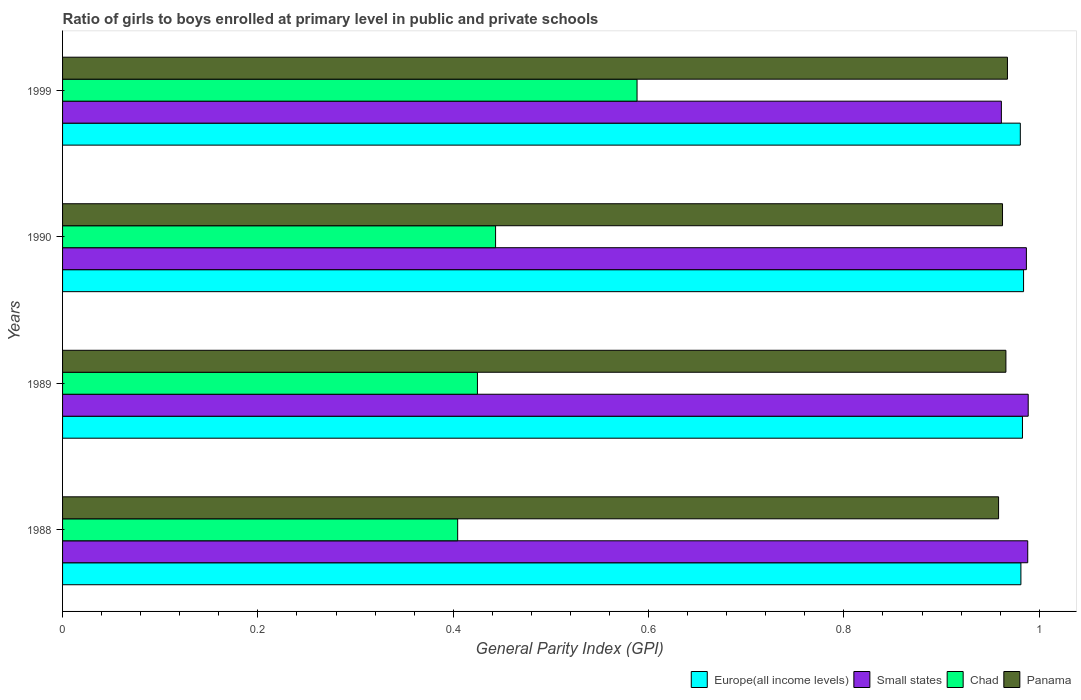How many different coloured bars are there?
Your answer should be very brief. 4. Are the number of bars per tick equal to the number of legend labels?
Ensure brevity in your answer.  Yes. Are the number of bars on each tick of the Y-axis equal?
Provide a short and direct response. Yes. How many bars are there on the 2nd tick from the bottom?
Give a very brief answer. 4. In how many cases, is the number of bars for a given year not equal to the number of legend labels?
Keep it short and to the point. 0. What is the general parity index in Panama in 1989?
Keep it short and to the point. 0.97. Across all years, what is the maximum general parity index in Small states?
Give a very brief answer. 0.99. Across all years, what is the minimum general parity index in Panama?
Give a very brief answer. 0.96. In which year was the general parity index in Panama minimum?
Offer a very short reply. 1988. What is the total general parity index in Chad in the graph?
Give a very brief answer. 1.86. What is the difference between the general parity index in Panama in 1989 and that in 1999?
Offer a terse response. -0. What is the difference between the general parity index in Panama in 1988 and the general parity index in Chad in 1989?
Give a very brief answer. 0.53. What is the average general parity index in Europe(all income levels) per year?
Keep it short and to the point. 0.98. In the year 1989, what is the difference between the general parity index in Europe(all income levels) and general parity index in Small states?
Make the answer very short. -0.01. In how many years, is the general parity index in Chad greater than 0.7600000000000001 ?
Ensure brevity in your answer.  0. What is the ratio of the general parity index in Europe(all income levels) in 1988 to that in 1989?
Ensure brevity in your answer.  1. Is the general parity index in Panama in 1989 less than that in 1990?
Offer a terse response. No. What is the difference between the highest and the second highest general parity index in Small states?
Give a very brief answer. 0. What is the difference between the highest and the lowest general parity index in Chad?
Make the answer very short. 0.18. In how many years, is the general parity index in Panama greater than the average general parity index in Panama taken over all years?
Offer a very short reply. 2. Is the sum of the general parity index in Europe(all income levels) in 1988 and 1989 greater than the maximum general parity index in Chad across all years?
Ensure brevity in your answer.  Yes. What does the 3rd bar from the top in 1988 represents?
Offer a terse response. Small states. What does the 2nd bar from the bottom in 1988 represents?
Make the answer very short. Small states. What is the difference between two consecutive major ticks on the X-axis?
Ensure brevity in your answer.  0.2. Does the graph contain grids?
Your response must be concise. No. How are the legend labels stacked?
Offer a terse response. Horizontal. What is the title of the graph?
Your answer should be compact. Ratio of girls to boys enrolled at primary level in public and private schools. What is the label or title of the X-axis?
Your response must be concise. General Parity Index (GPI). What is the General Parity Index (GPI) of Europe(all income levels) in 1988?
Your answer should be compact. 0.98. What is the General Parity Index (GPI) of Small states in 1988?
Your answer should be compact. 0.99. What is the General Parity Index (GPI) in Chad in 1988?
Your answer should be compact. 0.4. What is the General Parity Index (GPI) in Panama in 1988?
Offer a very short reply. 0.96. What is the General Parity Index (GPI) of Europe(all income levels) in 1989?
Offer a terse response. 0.98. What is the General Parity Index (GPI) of Small states in 1989?
Offer a very short reply. 0.99. What is the General Parity Index (GPI) of Chad in 1989?
Make the answer very short. 0.42. What is the General Parity Index (GPI) in Panama in 1989?
Provide a succinct answer. 0.97. What is the General Parity Index (GPI) of Europe(all income levels) in 1990?
Make the answer very short. 0.98. What is the General Parity Index (GPI) of Small states in 1990?
Offer a very short reply. 0.99. What is the General Parity Index (GPI) of Chad in 1990?
Your response must be concise. 0.44. What is the General Parity Index (GPI) in Panama in 1990?
Your response must be concise. 0.96. What is the General Parity Index (GPI) of Europe(all income levels) in 1999?
Ensure brevity in your answer.  0.98. What is the General Parity Index (GPI) in Small states in 1999?
Your response must be concise. 0.96. What is the General Parity Index (GPI) in Chad in 1999?
Your response must be concise. 0.59. What is the General Parity Index (GPI) of Panama in 1999?
Provide a short and direct response. 0.97. Across all years, what is the maximum General Parity Index (GPI) of Europe(all income levels)?
Offer a very short reply. 0.98. Across all years, what is the maximum General Parity Index (GPI) in Small states?
Give a very brief answer. 0.99. Across all years, what is the maximum General Parity Index (GPI) of Chad?
Your answer should be compact. 0.59. Across all years, what is the maximum General Parity Index (GPI) in Panama?
Provide a succinct answer. 0.97. Across all years, what is the minimum General Parity Index (GPI) in Europe(all income levels)?
Keep it short and to the point. 0.98. Across all years, what is the minimum General Parity Index (GPI) in Small states?
Your response must be concise. 0.96. Across all years, what is the minimum General Parity Index (GPI) in Chad?
Provide a succinct answer. 0.4. Across all years, what is the minimum General Parity Index (GPI) of Panama?
Your answer should be compact. 0.96. What is the total General Parity Index (GPI) in Europe(all income levels) in the graph?
Your answer should be compact. 3.93. What is the total General Parity Index (GPI) in Small states in the graph?
Keep it short and to the point. 3.93. What is the total General Parity Index (GPI) in Chad in the graph?
Your answer should be very brief. 1.86. What is the total General Parity Index (GPI) of Panama in the graph?
Provide a short and direct response. 3.85. What is the difference between the General Parity Index (GPI) of Europe(all income levels) in 1988 and that in 1989?
Offer a terse response. -0. What is the difference between the General Parity Index (GPI) of Small states in 1988 and that in 1989?
Provide a short and direct response. -0. What is the difference between the General Parity Index (GPI) of Chad in 1988 and that in 1989?
Ensure brevity in your answer.  -0.02. What is the difference between the General Parity Index (GPI) of Panama in 1988 and that in 1989?
Provide a short and direct response. -0.01. What is the difference between the General Parity Index (GPI) in Europe(all income levels) in 1988 and that in 1990?
Your response must be concise. -0. What is the difference between the General Parity Index (GPI) in Small states in 1988 and that in 1990?
Keep it short and to the point. 0. What is the difference between the General Parity Index (GPI) in Chad in 1988 and that in 1990?
Offer a very short reply. -0.04. What is the difference between the General Parity Index (GPI) of Panama in 1988 and that in 1990?
Provide a succinct answer. -0. What is the difference between the General Parity Index (GPI) in Europe(all income levels) in 1988 and that in 1999?
Provide a succinct answer. 0. What is the difference between the General Parity Index (GPI) of Small states in 1988 and that in 1999?
Keep it short and to the point. 0.03. What is the difference between the General Parity Index (GPI) of Chad in 1988 and that in 1999?
Keep it short and to the point. -0.18. What is the difference between the General Parity Index (GPI) of Panama in 1988 and that in 1999?
Provide a succinct answer. -0.01. What is the difference between the General Parity Index (GPI) of Europe(all income levels) in 1989 and that in 1990?
Make the answer very short. -0. What is the difference between the General Parity Index (GPI) in Small states in 1989 and that in 1990?
Ensure brevity in your answer.  0. What is the difference between the General Parity Index (GPI) in Chad in 1989 and that in 1990?
Give a very brief answer. -0.02. What is the difference between the General Parity Index (GPI) in Panama in 1989 and that in 1990?
Provide a succinct answer. 0. What is the difference between the General Parity Index (GPI) in Europe(all income levels) in 1989 and that in 1999?
Offer a very short reply. 0. What is the difference between the General Parity Index (GPI) of Small states in 1989 and that in 1999?
Your answer should be very brief. 0.03. What is the difference between the General Parity Index (GPI) of Chad in 1989 and that in 1999?
Ensure brevity in your answer.  -0.16. What is the difference between the General Parity Index (GPI) of Panama in 1989 and that in 1999?
Make the answer very short. -0. What is the difference between the General Parity Index (GPI) of Europe(all income levels) in 1990 and that in 1999?
Provide a short and direct response. 0. What is the difference between the General Parity Index (GPI) in Small states in 1990 and that in 1999?
Ensure brevity in your answer.  0.03. What is the difference between the General Parity Index (GPI) of Chad in 1990 and that in 1999?
Your answer should be very brief. -0.14. What is the difference between the General Parity Index (GPI) of Panama in 1990 and that in 1999?
Keep it short and to the point. -0.01. What is the difference between the General Parity Index (GPI) of Europe(all income levels) in 1988 and the General Parity Index (GPI) of Small states in 1989?
Make the answer very short. -0.01. What is the difference between the General Parity Index (GPI) of Europe(all income levels) in 1988 and the General Parity Index (GPI) of Chad in 1989?
Keep it short and to the point. 0.56. What is the difference between the General Parity Index (GPI) of Europe(all income levels) in 1988 and the General Parity Index (GPI) of Panama in 1989?
Provide a short and direct response. 0.02. What is the difference between the General Parity Index (GPI) in Small states in 1988 and the General Parity Index (GPI) in Chad in 1989?
Offer a very short reply. 0.56. What is the difference between the General Parity Index (GPI) of Small states in 1988 and the General Parity Index (GPI) of Panama in 1989?
Provide a short and direct response. 0.02. What is the difference between the General Parity Index (GPI) of Chad in 1988 and the General Parity Index (GPI) of Panama in 1989?
Offer a terse response. -0.56. What is the difference between the General Parity Index (GPI) in Europe(all income levels) in 1988 and the General Parity Index (GPI) in Small states in 1990?
Make the answer very short. -0.01. What is the difference between the General Parity Index (GPI) of Europe(all income levels) in 1988 and the General Parity Index (GPI) of Chad in 1990?
Offer a terse response. 0.54. What is the difference between the General Parity Index (GPI) of Europe(all income levels) in 1988 and the General Parity Index (GPI) of Panama in 1990?
Your response must be concise. 0.02. What is the difference between the General Parity Index (GPI) in Small states in 1988 and the General Parity Index (GPI) in Chad in 1990?
Make the answer very short. 0.54. What is the difference between the General Parity Index (GPI) in Small states in 1988 and the General Parity Index (GPI) in Panama in 1990?
Your answer should be compact. 0.03. What is the difference between the General Parity Index (GPI) of Chad in 1988 and the General Parity Index (GPI) of Panama in 1990?
Keep it short and to the point. -0.56. What is the difference between the General Parity Index (GPI) of Europe(all income levels) in 1988 and the General Parity Index (GPI) of Chad in 1999?
Your response must be concise. 0.39. What is the difference between the General Parity Index (GPI) of Europe(all income levels) in 1988 and the General Parity Index (GPI) of Panama in 1999?
Your answer should be compact. 0.01. What is the difference between the General Parity Index (GPI) of Small states in 1988 and the General Parity Index (GPI) of Panama in 1999?
Make the answer very short. 0.02. What is the difference between the General Parity Index (GPI) in Chad in 1988 and the General Parity Index (GPI) in Panama in 1999?
Offer a very short reply. -0.56. What is the difference between the General Parity Index (GPI) of Europe(all income levels) in 1989 and the General Parity Index (GPI) of Small states in 1990?
Provide a succinct answer. -0. What is the difference between the General Parity Index (GPI) of Europe(all income levels) in 1989 and the General Parity Index (GPI) of Chad in 1990?
Your answer should be compact. 0.54. What is the difference between the General Parity Index (GPI) in Europe(all income levels) in 1989 and the General Parity Index (GPI) in Panama in 1990?
Your response must be concise. 0.02. What is the difference between the General Parity Index (GPI) of Small states in 1989 and the General Parity Index (GPI) of Chad in 1990?
Offer a terse response. 0.55. What is the difference between the General Parity Index (GPI) in Small states in 1989 and the General Parity Index (GPI) in Panama in 1990?
Make the answer very short. 0.03. What is the difference between the General Parity Index (GPI) of Chad in 1989 and the General Parity Index (GPI) of Panama in 1990?
Your response must be concise. -0.54. What is the difference between the General Parity Index (GPI) of Europe(all income levels) in 1989 and the General Parity Index (GPI) of Small states in 1999?
Ensure brevity in your answer.  0.02. What is the difference between the General Parity Index (GPI) of Europe(all income levels) in 1989 and the General Parity Index (GPI) of Chad in 1999?
Offer a terse response. 0.39. What is the difference between the General Parity Index (GPI) in Europe(all income levels) in 1989 and the General Parity Index (GPI) in Panama in 1999?
Ensure brevity in your answer.  0.02. What is the difference between the General Parity Index (GPI) in Small states in 1989 and the General Parity Index (GPI) in Chad in 1999?
Ensure brevity in your answer.  0.4. What is the difference between the General Parity Index (GPI) of Small states in 1989 and the General Parity Index (GPI) of Panama in 1999?
Make the answer very short. 0.02. What is the difference between the General Parity Index (GPI) in Chad in 1989 and the General Parity Index (GPI) in Panama in 1999?
Give a very brief answer. -0.54. What is the difference between the General Parity Index (GPI) in Europe(all income levels) in 1990 and the General Parity Index (GPI) in Small states in 1999?
Offer a very short reply. 0.02. What is the difference between the General Parity Index (GPI) in Europe(all income levels) in 1990 and the General Parity Index (GPI) in Chad in 1999?
Provide a succinct answer. 0.4. What is the difference between the General Parity Index (GPI) in Europe(all income levels) in 1990 and the General Parity Index (GPI) in Panama in 1999?
Your response must be concise. 0.02. What is the difference between the General Parity Index (GPI) of Small states in 1990 and the General Parity Index (GPI) of Chad in 1999?
Ensure brevity in your answer.  0.4. What is the difference between the General Parity Index (GPI) of Small states in 1990 and the General Parity Index (GPI) of Panama in 1999?
Provide a succinct answer. 0.02. What is the difference between the General Parity Index (GPI) in Chad in 1990 and the General Parity Index (GPI) in Panama in 1999?
Your response must be concise. -0.52. What is the average General Parity Index (GPI) of Europe(all income levels) per year?
Offer a terse response. 0.98. What is the average General Parity Index (GPI) of Small states per year?
Ensure brevity in your answer.  0.98. What is the average General Parity Index (GPI) in Chad per year?
Provide a short and direct response. 0.47. What is the average General Parity Index (GPI) of Panama per year?
Provide a succinct answer. 0.96. In the year 1988, what is the difference between the General Parity Index (GPI) in Europe(all income levels) and General Parity Index (GPI) in Small states?
Offer a very short reply. -0.01. In the year 1988, what is the difference between the General Parity Index (GPI) in Europe(all income levels) and General Parity Index (GPI) in Chad?
Your answer should be very brief. 0.58. In the year 1988, what is the difference between the General Parity Index (GPI) of Europe(all income levels) and General Parity Index (GPI) of Panama?
Offer a terse response. 0.02. In the year 1988, what is the difference between the General Parity Index (GPI) of Small states and General Parity Index (GPI) of Chad?
Offer a very short reply. 0.58. In the year 1988, what is the difference between the General Parity Index (GPI) of Small states and General Parity Index (GPI) of Panama?
Provide a succinct answer. 0.03. In the year 1988, what is the difference between the General Parity Index (GPI) in Chad and General Parity Index (GPI) in Panama?
Ensure brevity in your answer.  -0.55. In the year 1989, what is the difference between the General Parity Index (GPI) in Europe(all income levels) and General Parity Index (GPI) in Small states?
Your answer should be compact. -0.01. In the year 1989, what is the difference between the General Parity Index (GPI) in Europe(all income levels) and General Parity Index (GPI) in Chad?
Offer a very short reply. 0.56. In the year 1989, what is the difference between the General Parity Index (GPI) of Europe(all income levels) and General Parity Index (GPI) of Panama?
Offer a very short reply. 0.02. In the year 1989, what is the difference between the General Parity Index (GPI) of Small states and General Parity Index (GPI) of Chad?
Keep it short and to the point. 0.56. In the year 1989, what is the difference between the General Parity Index (GPI) in Small states and General Parity Index (GPI) in Panama?
Your answer should be compact. 0.02. In the year 1989, what is the difference between the General Parity Index (GPI) of Chad and General Parity Index (GPI) of Panama?
Offer a very short reply. -0.54. In the year 1990, what is the difference between the General Parity Index (GPI) of Europe(all income levels) and General Parity Index (GPI) of Small states?
Offer a terse response. -0. In the year 1990, what is the difference between the General Parity Index (GPI) in Europe(all income levels) and General Parity Index (GPI) in Chad?
Provide a short and direct response. 0.54. In the year 1990, what is the difference between the General Parity Index (GPI) of Europe(all income levels) and General Parity Index (GPI) of Panama?
Your answer should be very brief. 0.02. In the year 1990, what is the difference between the General Parity Index (GPI) of Small states and General Parity Index (GPI) of Chad?
Offer a terse response. 0.54. In the year 1990, what is the difference between the General Parity Index (GPI) in Small states and General Parity Index (GPI) in Panama?
Your answer should be very brief. 0.02. In the year 1990, what is the difference between the General Parity Index (GPI) in Chad and General Parity Index (GPI) in Panama?
Your response must be concise. -0.52. In the year 1999, what is the difference between the General Parity Index (GPI) of Europe(all income levels) and General Parity Index (GPI) of Small states?
Give a very brief answer. 0.02. In the year 1999, what is the difference between the General Parity Index (GPI) of Europe(all income levels) and General Parity Index (GPI) of Chad?
Offer a terse response. 0.39. In the year 1999, what is the difference between the General Parity Index (GPI) of Europe(all income levels) and General Parity Index (GPI) of Panama?
Give a very brief answer. 0.01. In the year 1999, what is the difference between the General Parity Index (GPI) in Small states and General Parity Index (GPI) in Chad?
Offer a very short reply. 0.37. In the year 1999, what is the difference between the General Parity Index (GPI) of Small states and General Parity Index (GPI) of Panama?
Give a very brief answer. -0.01. In the year 1999, what is the difference between the General Parity Index (GPI) of Chad and General Parity Index (GPI) of Panama?
Your response must be concise. -0.38. What is the ratio of the General Parity Index (GPI) in Europe(all income levels) in 1988 to that in 1989?
Your answer should be very brief. 1. What is the ratio of the General Parity Index (GPI) in Chad in 1988 to that in 1989?
Keep it short and to the point. 0.95. What is the ratio of the General Parity Index (GPI) of Panama in 1988 to that in 1989?
Offer a very short reply. 0.99. What is the ratio of the General Parity Index (GPI) of Small states in 1988 to that in 1990?
Make the answer very short. 1. What is the ratio of the General Parity Index (GPI) of Chad in 1988 to that in 1990?
Make the answer very short. 0.91. What is the ratio of the General Parity Index (GPI) in Europe(all income levels) in 1988 to that in 1999?
Your answer should be very brief. 1. What is the ratio of the General Parity Index (GPI) in Small states in 1988 to that in 1999?
Your answer should be very brief. 1.03. What is the ratio of the General Parity Index (GPI) of Chad in 1988 to that in 1999?
Give a very brief answer. 0.69. What is the ratio of the General Parity Index (GPI) of Panama in 1988 to that in 1999?
Ensure brevity in your answer.  0.99. What is the ratio of the General Parity Index (GPI) of Europe(all income levels) in 1989 to that in 1990?
Your answer should be very brief. 1. What is the ratio of the General Parity Index (GPI) in Small states in 1989 to that in 1990?
Your answer should be very brief. 1. What is the ratio of the General Parity Index (GPI) in Chad in 1989 to that in 1990?
Your answer should be very brief. 0.96. What is the ratio of the General Parity Index (GPI) in Europe(all income levels) in 1989 to that in 1999?
Keep it short and to the point. 1. What is the ratio of the General Parity Index (GPI) in Small states in 1989 to that in 1999?
Ensure brevity in your answer.  1.03. What is the ratio of the General Parity Index (GPI) of Chad in 1989 to that in 1999?
Your answer should be very brief. 0.72. What is the ratio of the General Parity Index (GPI) in Panama in 1989 to that in 1999?
Offer a very short reply. 1. What is the ratio of the General Parity Index (GPI) of Small states in 1990 to that in 1999?
Offer a very short reply. 1.03. What is the ratio of the General Parity Index (GPI) of Chad in 1990 to that in 1999?
Make the answer very short. 0.75. What is the ratio of the General Parity Index (GPI) of Panama in 1990 to that in 1999?
Provide a succinct answer. 0.99. What is the difference between the highest and the second highest General Parity Index (GPI) of Europe(all income levels)?
Your answer should be very brief. 0. What is the difference between the highest and the second highest General Parity Index (GPI) in Chad?
Ensure brevity in your answer.  0.14. What is the difference between the highest and the second highest General Parity Index (GPI) in Panama?
Your answer should be very brief. 0. What is the difference between the highest and the lowest General Parity Index (GPI) in Europe(all income levels)?
Ensure brevity in your answer.  0. What is the difference between the highest and the lowest General Parity Index (GPI) of Small states?
Offer a terse response. 0.03. What is the difference between the highest and the lowest General Parity Index (GPI) of Chad?
Keep it short and to the point. 0.18. What is the difference between the highest and the lowest General Parity Index (GPI) of Panama?
Give a very brief answer. 0.01. 